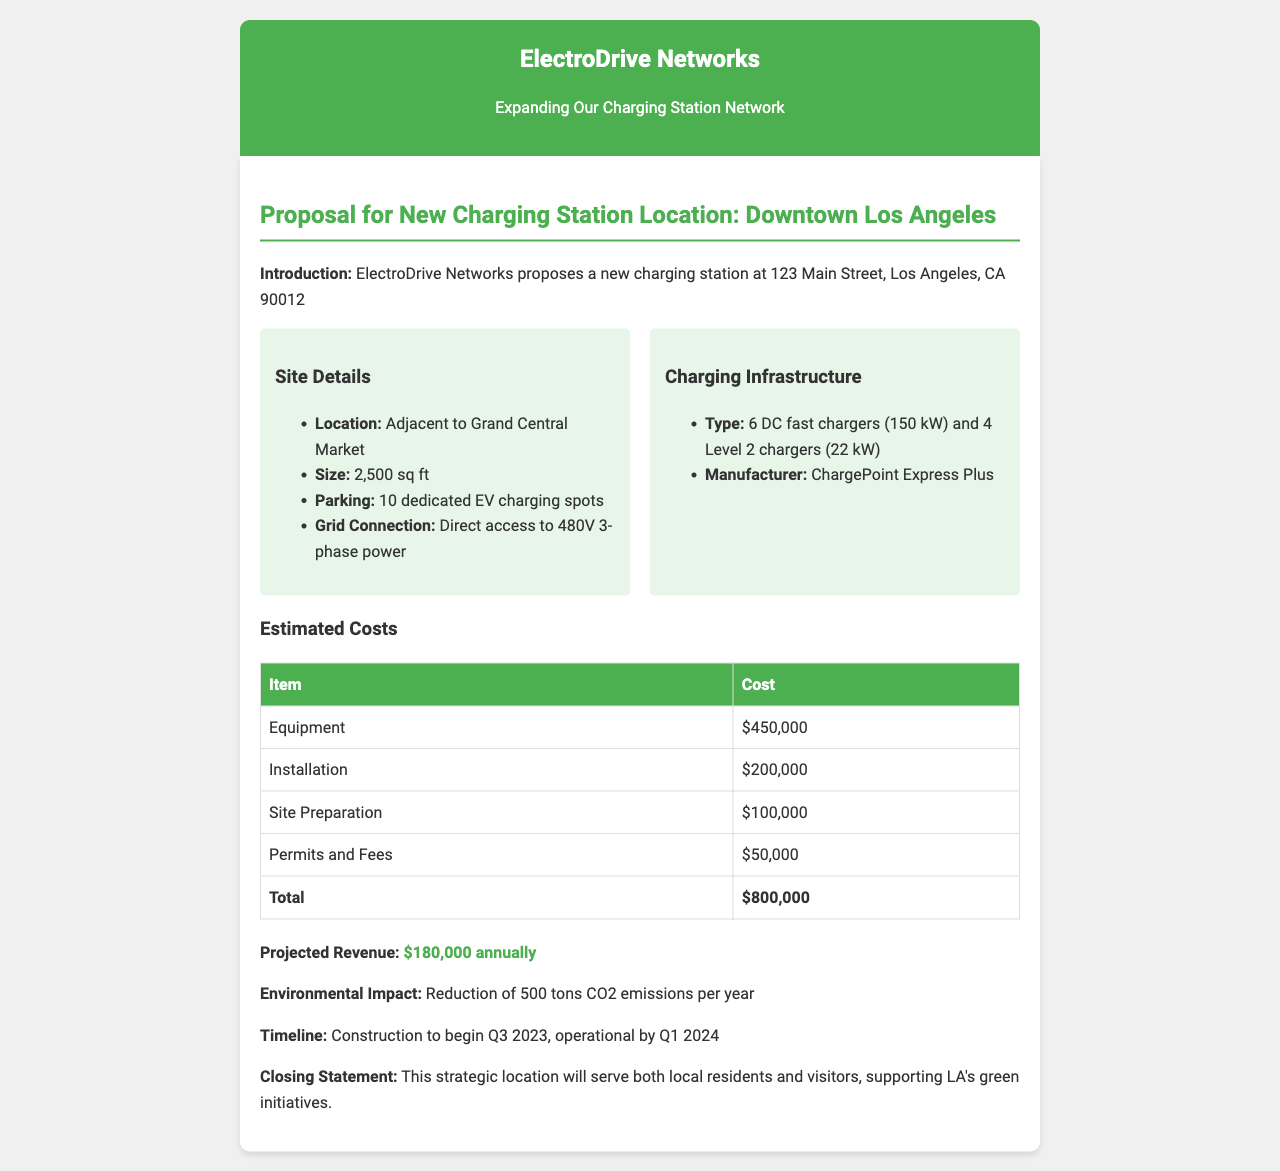what is the location of the new charging station? The proposal states that the new charging station will be located at 123 Main Street, Los Angeles, CA 90012.
Answer: 123 Main Street, Los Angeles, CA 90012 how many DC fast chargers will be installed? The document specifies that 6 DC fast chargers will be part of the charging infrastructure.
Answer: 6 DC fast chargers what is the total estimated cost for the project? The total estimated cost is provided in the document as the sum of all components listed, which is $800,000.
Answer: $800,000 when is the construction scheduled to begin? The document mentions that construction will begin in the 3rd quarter of 2023.
Answer: Q3 2023 what is the size of the site in square feet? The proposal indicates that the charging station will occupy 2,500 square feet.
Answer: 2,500 sq ft what is the projected annual revenue from the charging station? The document outlines that the projected revenue is $180,000 annually.
Answer: $180,000 annually how many Level 2 chargers will be installed? According to the charging infrastructure details, there will be 4 Level 2 chargers.
Answer: 4 Level 2 chargers what is the expected reduction of CO2 emissions per year? The document states that the charging station will lead to a reduction of 500 tons of CO2 emissions annually.
Answer: 500 tons CO2 emissions per year 